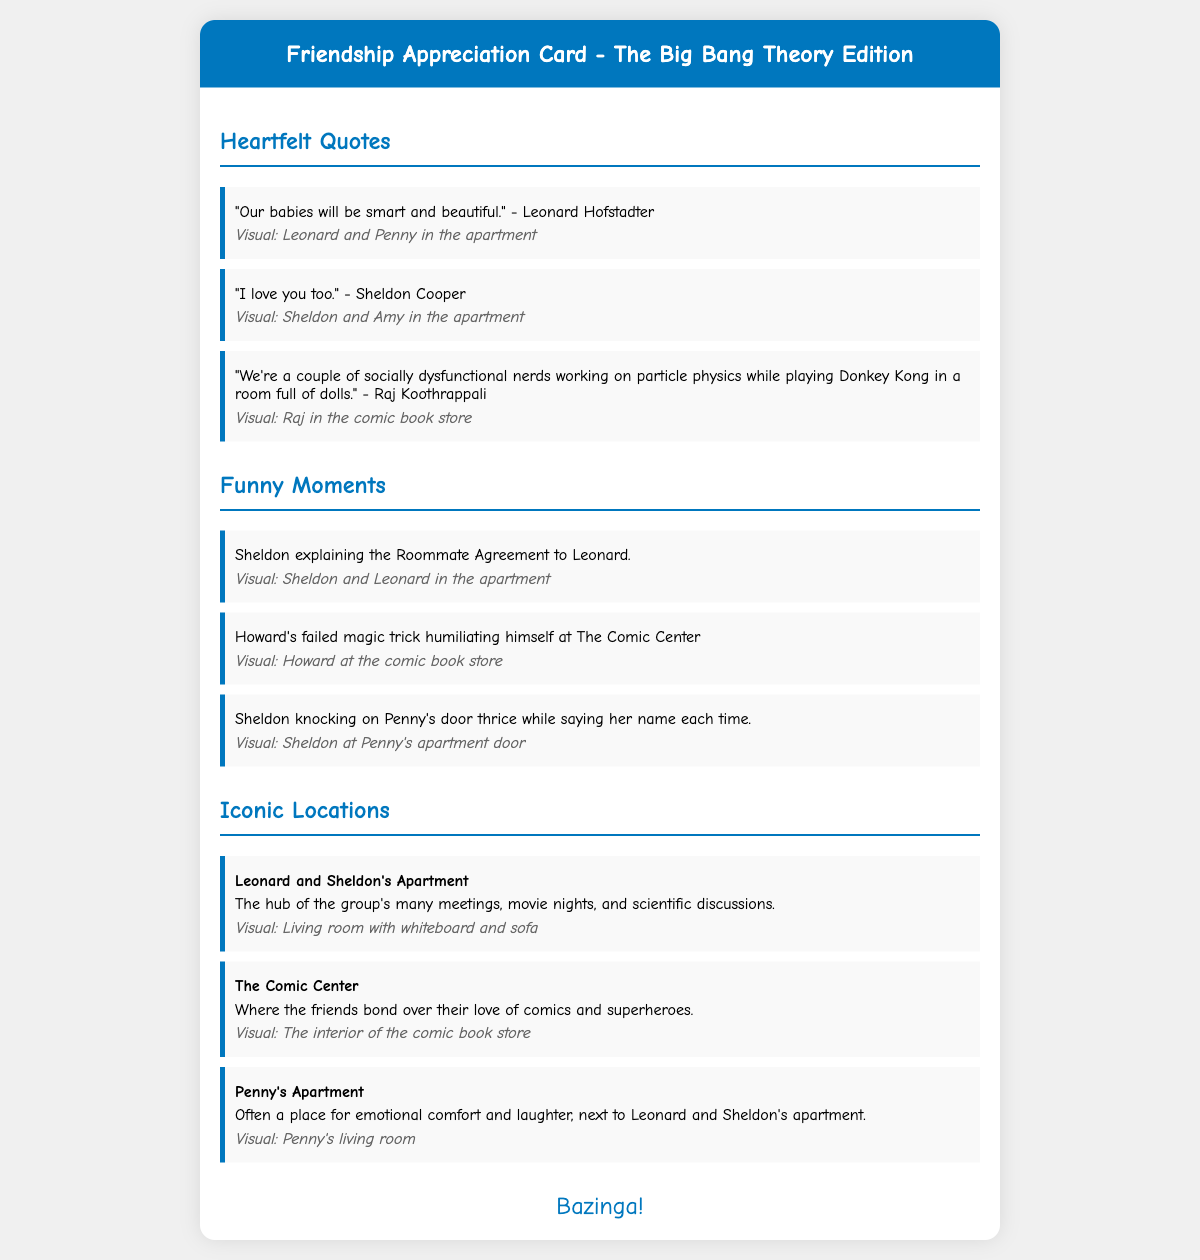What is the title of the card? The title of the card is stated at the top of the document in the header section.
Answer: Friendship Appreciation Card - The Big Bang Theory Edition Who says, "Our babies will be smart and beautiful"? This quote is attributed to a character in the heartfelt quotes section of the card.
Answer: Leonard Hofstadter What is the first funny moment mentioned? This information can be found in the funny moments section describing a memorable scene from the show.
Answer: Sheldon explaining the Roommate Agreement to Leonard What location is described as the hub of the group's many meetings? The document specifies a location that is known for hosting the group's interactions and activities.
Answer: Leonard and Sheldon's Apartment What phrase does Sheldon famously use when something surprising happens? This catchphrase is often associated with Sheldon's character in the series and is included at the bottom of the card.
Answer: Bazinga! 